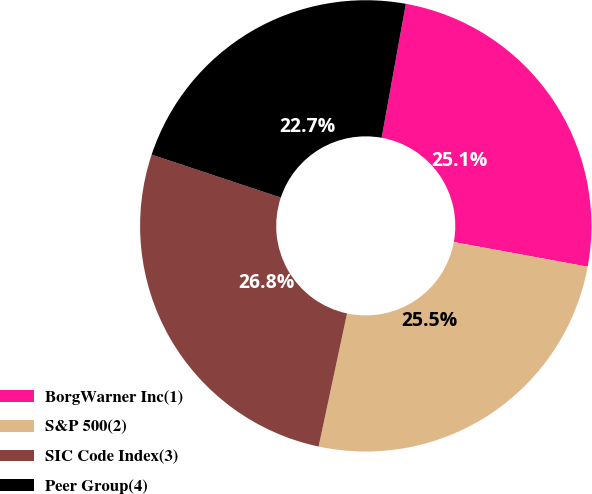Convert chart to OTSL. <chart><loc_0><loc_0><loc_500><loc_500><pie_chart><fcel>BorgWarner Inc(1)<fcel>S&P 500(2)<fcel>SIC Code Index(3)<fcel>Peer Group(4)<nl><fcel>25.05%<fcel>25.45%<fcel>26.76%<fcel>22.73%<nl></chart> 